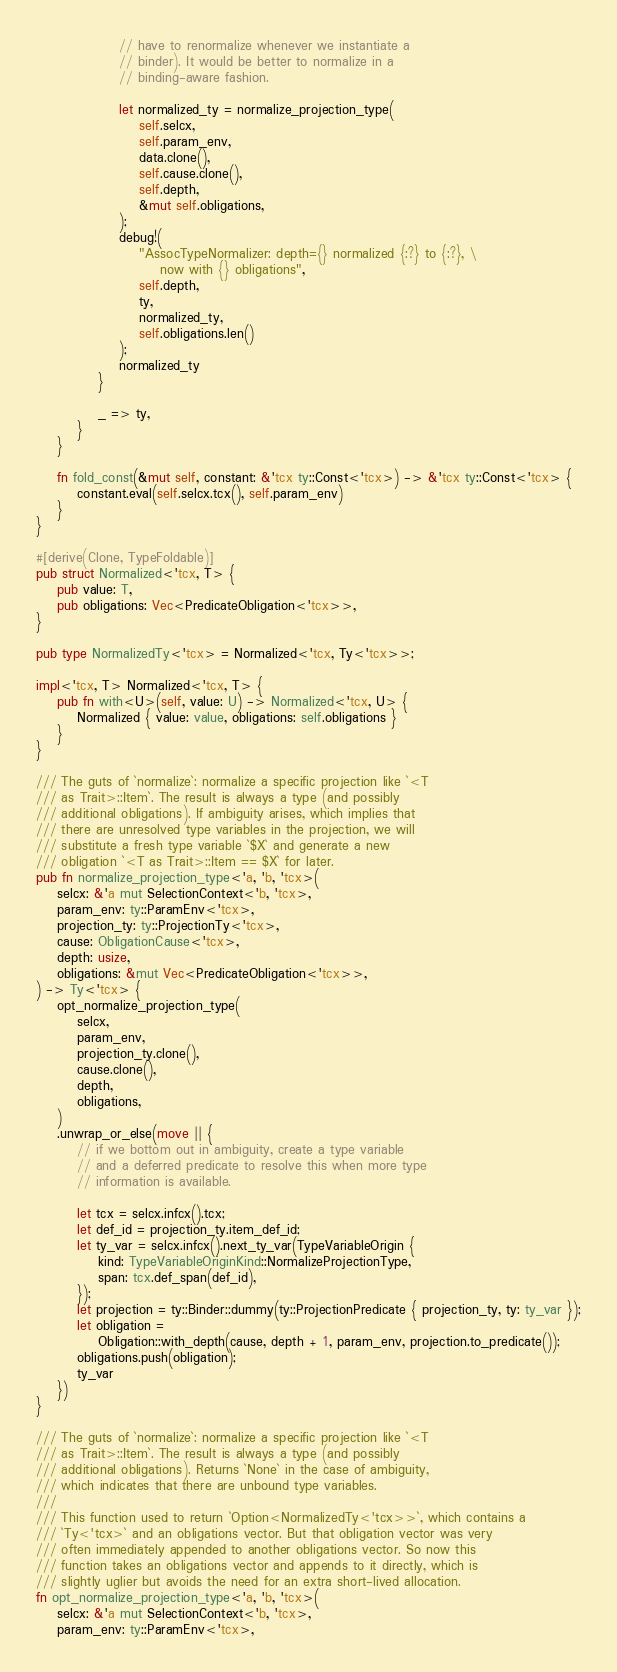<code> <loc_0><loc_0><loc_500><loc_500><_Rust_>                // have to renormalize whenever we instantiate a
                // binder). It would be better to normalize in a
                // binding-aware fashion.

                let normalized_ty = normalize_projection_type(
                    self.selcx,
                    self.param_env,
                    data.clone(),
                    self.cause.clone(),
                    self.depth,
                    &mut self.obligations,
                );
                debug!(
                    "AssocTypeNormalizer: depth={} normalized {:?} to {:?}, \
                        now with {} obligations",
                    self.depth,
                    ty,
                    normalized_ty,
                    self.obligations.len()
                );
                normalized_ty
            }

            _ => ty,
        }
    }

    fn fold_const(&mut self, constant: &'tcx ty::Const<'tcx>) -> &'tcx ty::Const<'tcx> {
        constant.eval(self.selcx.tcx(), self.param_env)
    }
}

#[derive(Clone, TypeFoldable)]
pub struct Normalized<'tcx, T> {
    pub value: T,
    pub obligations: Vec<PredicateObligation<'tcx>>,
}

pub type NormalizedTy<'tcx> = Normalized<'tcx, Ty<'tcx>>;

impl<'tcx, T> Normalized<'tcx, T> {
    pub fn with<U>(self, value: U) -> Normalized<'tcx, U> {
        Normalized { value: value, obligations: self.obligations }
    }
}

/// The guts of `normalize`: normalize a specific projection like `<T
/// as Trait>::Item`. The result is always a type (and possibly
/// additional obligations). If ambiguity arises, which implies that
/// there are unresolved type variables in the projection, we will
/// substitute a fresh type variable `$X` and generate a new
/// obligation `<T as Trait>::Item == $X` for later.
pub fn normalize_projection_type<'a, 'b, 'tcx>(
    selcx: &'a mut SelectionContext<'b, 'tcx>,
    param_env: ty::ParamEnv<'tcx>,
    projection_ty: ty::ProjectionTy<'tcx>,
    cause: ObligationCause<'tcx>,
    depth: usize,
    obligations: &mut Vec<PredicateObligation<'tcx>>,
) -> Ty<'tcx> {
    opt_normalize_projection_type(
        selcx,
        param_env,
        projection_ty.clone(),
        cause.clone(),
        depth,
        obligations,
    )
    .unwrap_or_else(move || {
        // if we bottom out in ambiguity, create a type variable
        // and a deferred predicate to resolve this when more type
        // information is available.

        let tcx = selcx.infcx().tcx;
        let def_id = projection_ty.item_def_id;
        let ty_var = selcx.infcx().next_ty_var(TypeVariableOrigin {
            kind: TypeVariableOriginKind::NormalizeProjectionType,
            span: tcx.def_span(def_id),
        });
        let projection = ty::Binder::dummy(ty::ProjectionPredicate { projection_ty, ty: ty_var });
        let obligation =
            Obligation::with_depth(cause, depth + 1, param_env, projection.to_predicate());
        obligations.push(obligation);
        ty_var
    })
}

/// The guts of `normalize`: normalize a specific projection like `<T
/// as Trait>::Item`. The result is always a type (and possibly
/// additional obligations). Returns `None` in the case of ambiguity,
/// which indicates that there are unbound type variables.
///
/// This function used to return `Option<NormalizedTy<'tcx>>`, which contains a
/// `Ty<'tcx>` and an obligations vector. But that obligation vector was very
/// often immediately appended to another obligations vector. So now this
/// function takes an obligations vector and appends to it directly, which is
/// slightly uglier but avoids the need for an extra short-lived allocation.
fn opt_normalize_projection_type<'a, 'b, 'tcx>(
    selcx: &'a mut SelectionContext<'b, 'tcx>,
    param_env: ty::ParamEnv<'tcx>,</code> 